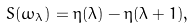Convert formula to latex. <formula><loc_0><loc_0><loc_500><loc_500>S ( \omega _ { \lambda } ) = \eta ( \lambda ) - \eta ( \lambda + 1 ) ,</formula> 